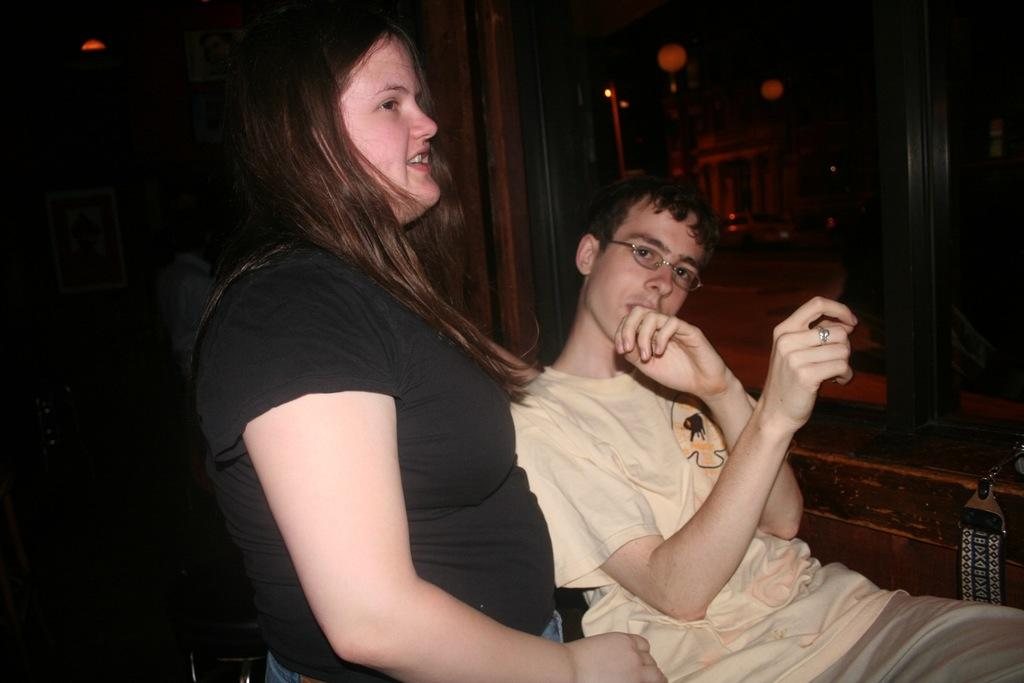How many people are in the image? There are two people in the image, a boy and a girl. Can you describe the appearance of the boy and the girl? Unfortunately, the provided facts do not include any information about the appearance of the boy and the girl. What can be said about the background of the image? The background of the image is not clear enough to describe the objects. What type of root can be seen growing in the image? There is no root present in the image; it features a boy and a girl. What is the argument about in the image? There is no argument present in the image; it features a boy and a girl. 